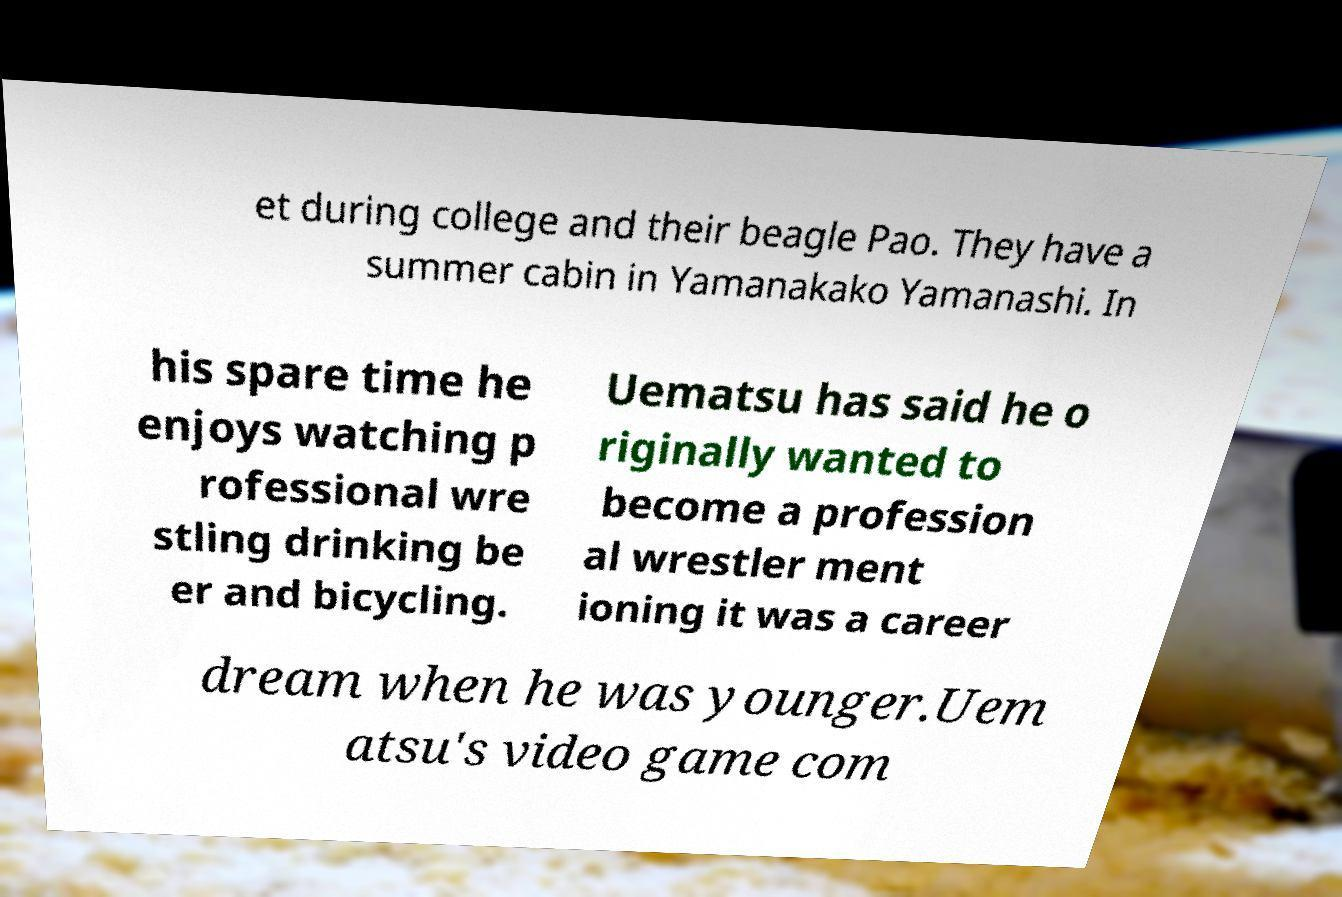Could you assist in decoding the text presented in this image and type it out clearly? et during college and their beagle Pao. They have a summer cabin in Yamanakako Yamanashi. In his spare time he enjoys watching p rofessional wre stling drinking be er and bicycling. Uematsu has said he o riginally wanted to become a profession al wrestler ment ioning it was a career dream when he was younger.Uem atsu's video game com 